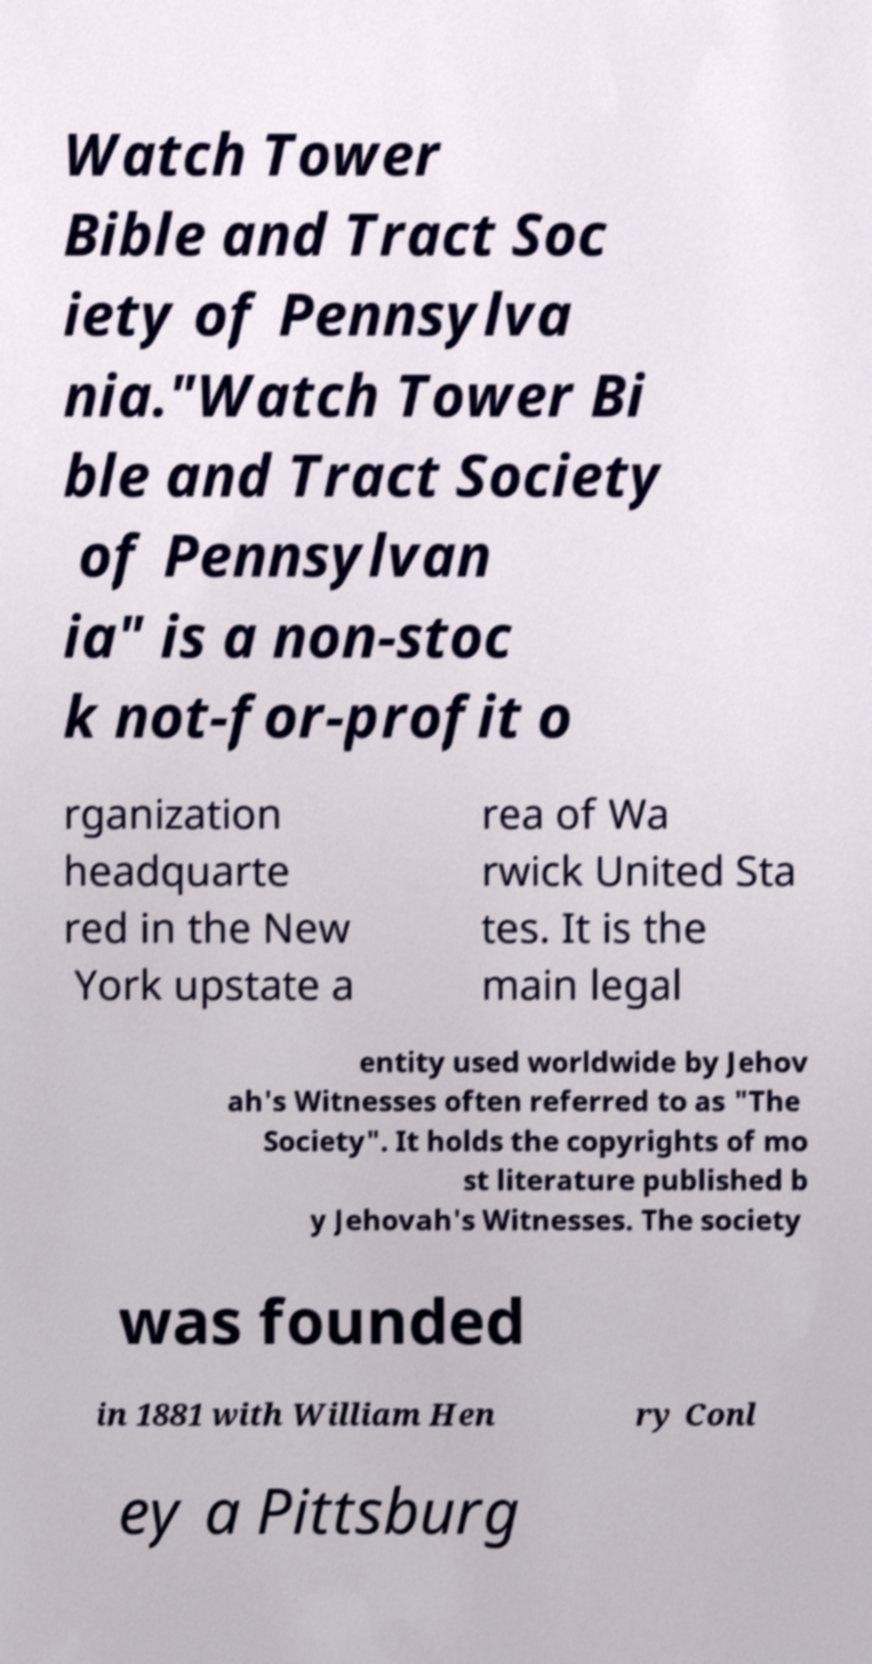Can you accurately transcribe the text from the provided image for me? Watch Tower Bible and Tract Soc iety of Pennsylva nia."Watch Tower Bi ble and Tract Society of Pennsylvan ia" is a non-stoc k not-for-profit o rganization headquarte red in the New York upstate a rea of Wa rwick United Sta tes. It is the main legal entity used worldwide by Jehov ah's Witnesses often referred to as "The Society". It holds the copyrights of mo st literature published b y Jehovah's Witnesses. The society was founded in 1881 with William Hen ry Conl ey a Pittsburg 